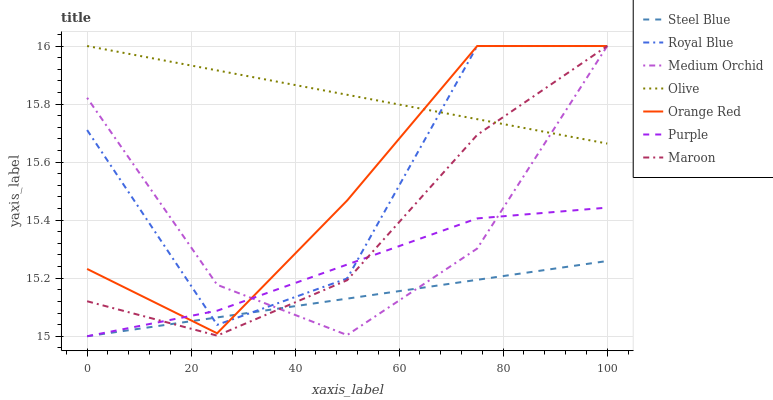Does Steel Blue have the minimum area under the curve?
Answer yes or no. Yes. Does Olive have the maximum area under the curve?
Answer yes or no. Yes. Does Medium Orchid have the minimum area under the curve?
Answer yes or no. No. Does Medium Orchid have the maximum area under the curve?
Answer yes or no. No. Is Olive the smoothest?
Answer yes or no. Yes. Is Royal Blue the roughest?
Answer yes or no. Yes. Is Medium Orchid the smoothest?
Answer yes or no. No. Is Medium Orchid the roughest?
Answer yes or no. No. Does Purple have the lowest value?
Answer yes or no. Yes. Does Medium Orchid have the lowest value?
Answer yes or no. No. Does Orange Red have the highest value?
Answer yes or no. Yes. Does Steel Blue have the highest value?
Answer yes or no. No. Is Purple less than Olive?
Answer yes or no. Yes. Is Olive greater than Purple?
Answer yes or no. Yes. Does Orange Red intersect Purple?
Answer yes or no. Yes. Is Orange Red less than Purple?
Answer yes or no. No. Is Orange Red greater than Purple?
Answer yes or no. No. Does Purple intersect Olive?
Answer yes or no. No. 